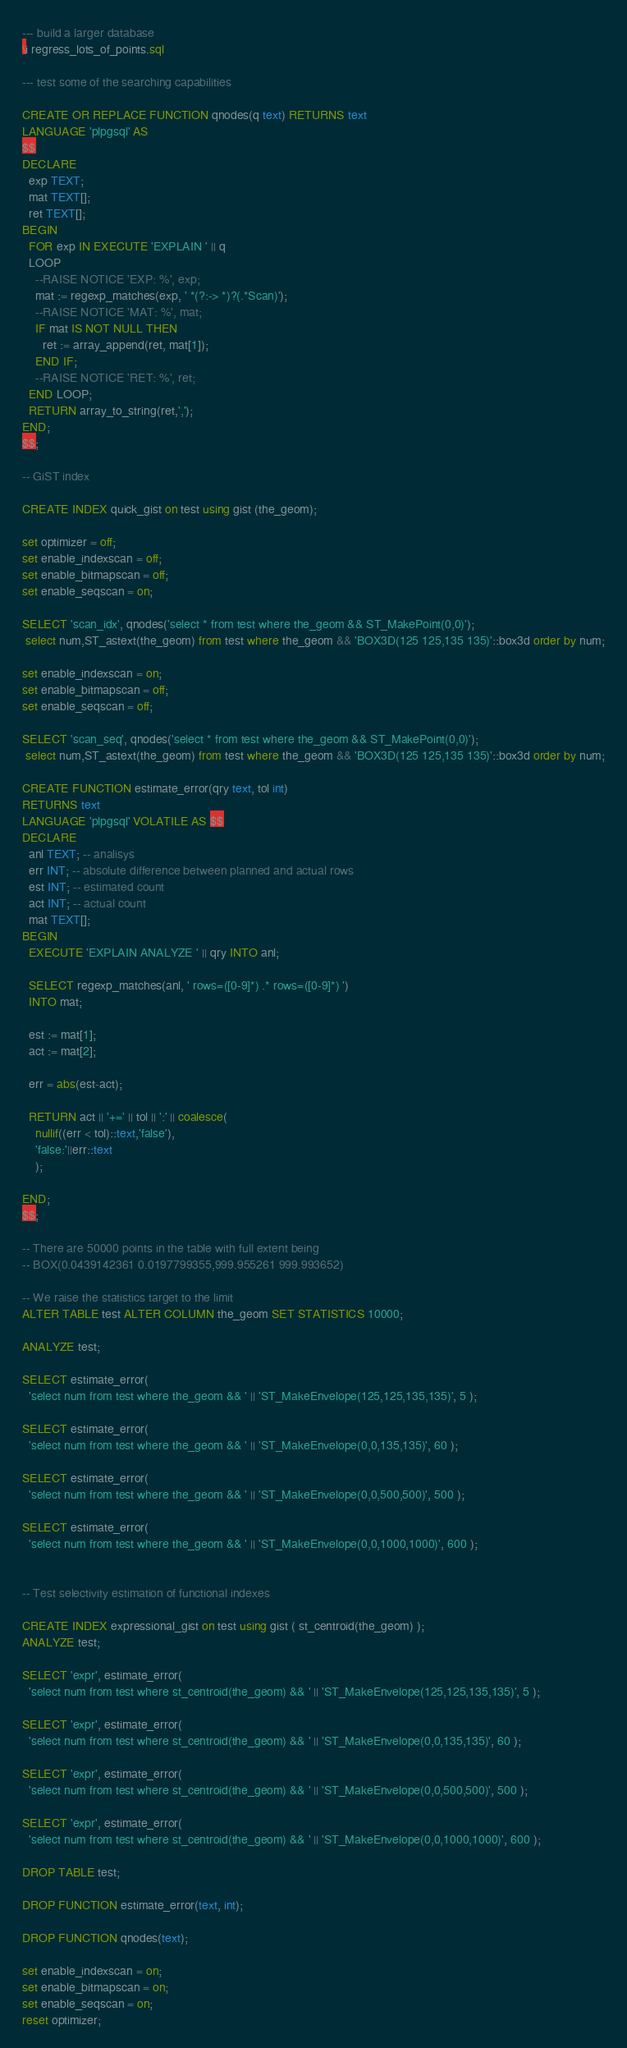<code> <loc_0><loc_0><loc_500><loc_500><_SQL_>--- build a larger database
\i regress_lots_of_points.sql

--- test some of the searching capabilities

CREATE OR REPLACE FUNCTION qnodes(q text) RETURNS text
LANGUAGE 'plpgsql' AS
$$
DECLARE
  exp TEXT;
  mat TEXT[];
  ret TEXT[];
BEGIN
  FOR exp IN EXECUTE 'EXPLAIN ' || q
  LOOP
    --RAISE NOTICE 'EXP: %', exp;
    mat := regexp_matches(exp, ' *(?:-> *)?(.*Scan)');
    --RAISE NOTICE 'MAT: %', mat;
    IF mat IS NOT NULL THEN
      ret := array_append(ret, mat[1]);
    END IF;
    --RAISE NOTICE 'RET: %', ret;
  END LOOP;
  RETURN array_to_string(ret,',');
END;
$$;

-- GiST index

CREATE INDEX quick_gist on test using gist (the_geom);

set optimizer = off;
set enable_indexscan = off;
set enable_bitmapscan = off;
set enable_seqscan = on;

SELECT 'scan_idx', qnodes('select * from test where the_geom && ST_MakePoint(0,0)');
 select num,ST_astext(the_geom) from test where the_geom && 'BOX3D(125 125,135 135)'::box3d order by num;

set enable_indexscan = on;
set enable_bitmapscan = off;
set enable_seqscan = off;

SELECT 'scan_seq', qnodes('select * from test where the_geom && ST_MakePoint(0,0)');
 select num,ST_astext(the_geom) from test where the_geom && 'BOX3D(125 125,135 135)'::box3d order by num;

CREATE FUNCTION estimate_error(qry text, tol int)
RETURNS text
LANGUAGE 'plpgsql' VOLATILE AS $$
DECLARE
  anl TEXT; -- analisys
  err INT; -- absolute difference between planned and actual rows
  est INT; -- estimated count
  act INT; -- actual count
  mat TEXT[];
BEGIN
  EXECUTE 'EXPLAIN ANALYZE ' || qry INTO anl;

  SELECT regexp_matches(anl, ' rows=([0-9]*) .* rows=([0-9]*) ')
  INTO mat;

  est := mat[1];
  act := mat[2];

  err = abs(est-act);

  RETURN act || '+=' || tol || ':' || coalesce(
    nullif((err < tol)::text,'false'),
    'false:'||err::text
    );

END;
$$;

-- There are 50000 points in the table with full extent being
-- BOX(0.0439142361 0.0197799355,999.955261 999.993652)

-- We raise the statistics target to the limit
ALTER TABLE test ALTER COLUMN the_geom SET STATISTICS 10000;

ANALYZE test;

SELECT estimate_error(
  'select num from test where the_geom && ' || 'ST_MakeEnvelope(125,125,135,135)', 5 );

SELECT estimate_error(
  'select num from test where the_geom && ' || 'ST_MakeEnvelope(0,0,135,135)', 60 );

SELECT estimate_error(
  'select num from test where the_geom && ' || 'ST_MakeEnvelope(0,0,500,500)', 500 );

SELECT estimate_error(
  'select num from test where the_geom && ' || 'ST_MakeEnvelope(0,0,1000,1000)', 600 );


-- Test selectivity estimation of functional indexes

CREATE INDEX expressional_gist on test using gist ( st_centroid(the_geom) );
ANALYZE test;

SELECT 'expr', estimate_error(
  'select num from test where st_centroid(the_geom) && ' || 'ST_MakeEnvelope(125,125,135,135)', 5 );

SELECT 'expr', estimate_error(
  'select num from test where st_centroid(the_geom) && ' || 'ST_MakeEnvelope(0,0,135,135)', 60 );

SELECT 'expr', estimate_error(
  'select num from test where st_centroid(the_geom) && ' || 'ST_MakeEnvelope(0,0,500,500)', 500 );

SELECT 'expr', estimate_error(
  'select num from test where st_centroid(the_geom) && ' || 'ST_MakeEnvelope(0,0,1000,1000)', 600 );

DROP TABLE test;

DROP FUNCTION estimate_error(text, int);

DROP FUNCTION qnodes(text);

set enable_indexscan = on;
set enable_bitmapscan = on;
set enable_seqscan = on;
reset optimizer;
</code> 